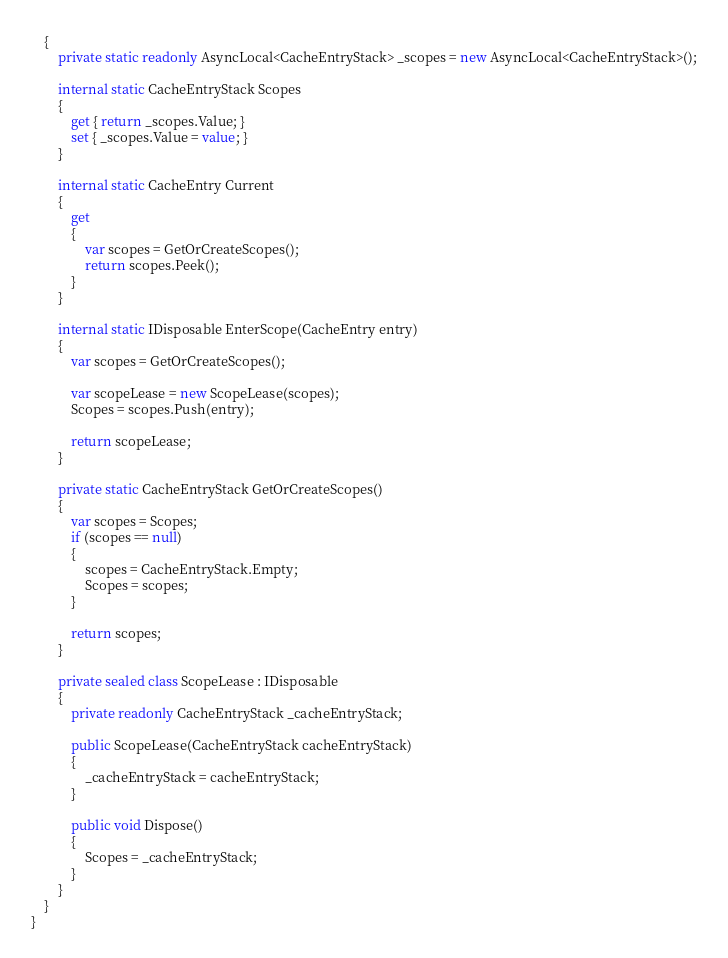Convert code to text. <code><loc_0><loc_0><loc_500><loc_500><_C#_>    {
        private static readonly AsyncLocal<CacheEntryStack> _scopes = new AsyncLocal<CacheEntryStack>();

        internal static CacheEntryStack Scopes
        {
            get { return _scopes.Value; }
            set { _scopes.Value = value; }
        }

        internal static CacheEntry Current
        {
            get
            {
                var scopes = GetOrCreateScopes();
                return scopes.Peek();
            }
        }

        internal static IDisposable EnterScope(CacheEntry entry)
        {
            var scopes = GetOrCreateScopes();

            var scopeLease = new ScopeLease(scopes);
            Scopes = scopes.Push(entry);

            return scopeLease;
        }

        private static CacheEntryStack GetOrCreateScopes()
        {
            var scopes = Scopes;
            if (scopes == null)
            {
                scopes = CacheEntryStack.Empty;
                Scopes = scopes;
            }

            return scopes;
        }

        private sealed class ScopeLease : IDisposable
        {
            private readonly CacheEntryStack _cacheEntryStack;

            public ScopeLease(CacheEntryStack cacheEntryStack)
            {
                _cacheEntryStack = cacheEntryStack;
            }

            public void Dispose()
            {
                Scopes = _cacheEntryStack;
            }
        }
    }
}</code> 